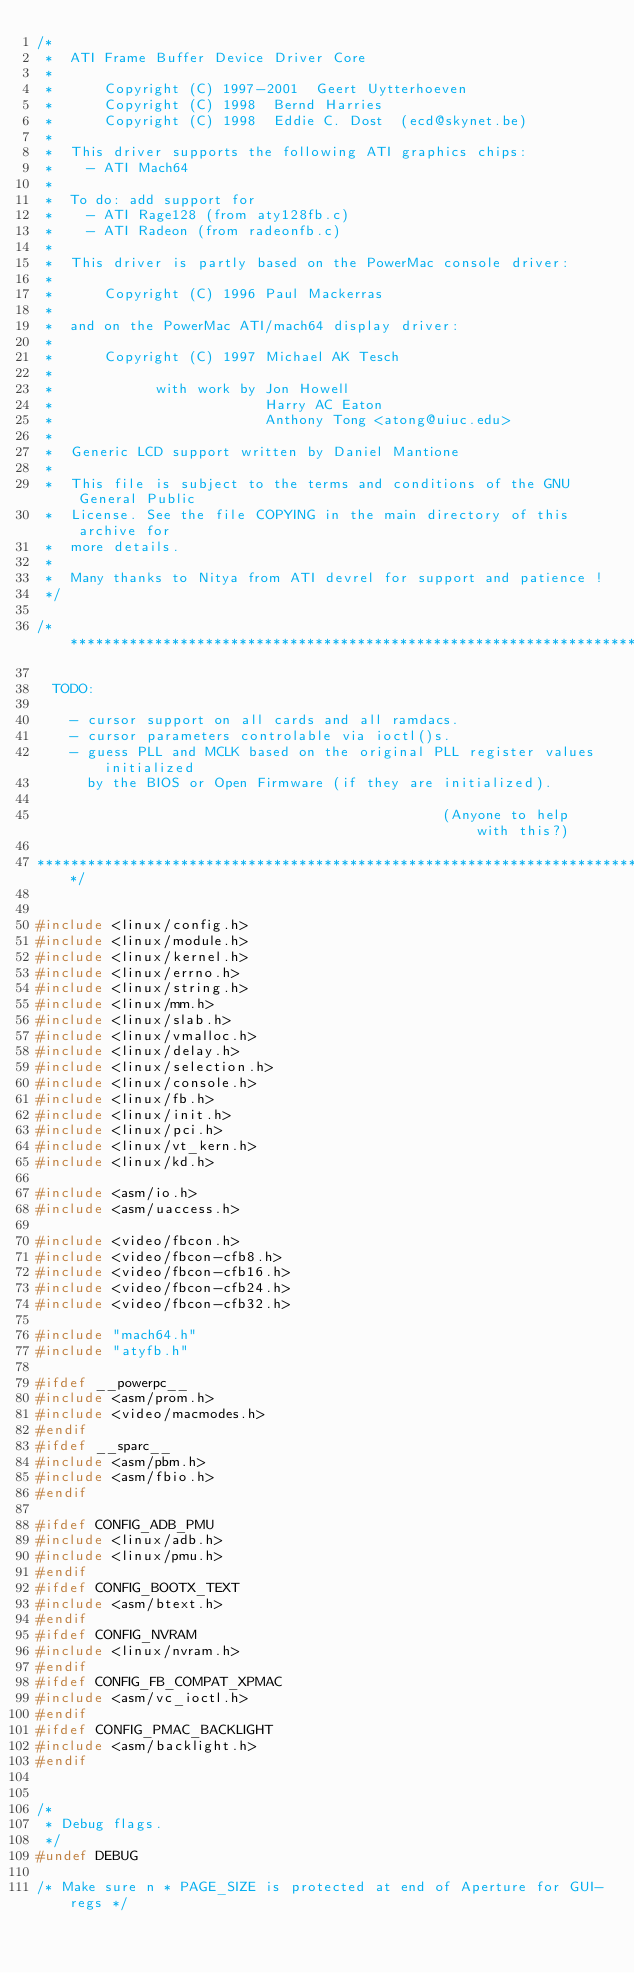<code> <loc_0><loc_0><loc_500><loc_500><_C_>/*
 *  ATI Frame Buffer Device Driver Core
 *
 *      Copyright (C) 1997-2001  Geert Uytterhoeven
 *      Copyright (C) 1998  Bernd Harries
 *      Copyright (C) 1998  Eddie C. Dost  (ecd@skynet.be)
 *
 *  This driver supports the following ATI graphics chips:
 *    - ATI Mach64
 *
 *  To do: add support for
 *    - ATI Rage128 (from aty128fb.c)
 *    - ATI Radeon (from radeonfb.c)
 *
 *  This driver is partly based on the PowerMac console driver:
 *
 *      Copyright (C) 1996 Paul Mackerras
 *
 *  and on the PowerMac ATI/mach64 display driver:
 *
 *      Copyright (C) 1997 Michael AK Tesch
 *
 *            with work by Jon Howell
 *                         Harry AC Eaton
 *                         Anthony Tong <atong@uiuc.edu>
 *
 *  Generic LCD support written by Daniel Mantione
 *
 *  This file is subject to the terms and conditions of the GNU General Public
 *  License. See the file COPYING in the main directory of this archive for
 *  more details.
 *  
 *  Many thanks to Nitya from ATI devrel for support and patience !
 */

/******************************************************************************

  TODO:

    - cursor support on all cards and all ramdacs.
    - cursor parameters controlable via ioctl()s.
    - guess PLL and MCLK based on the original PLL register values initialized
      by the BIOS or Open Firmware (if they are initialized).

                                                (Anyone to help with this?)

******************************************************************************/


#include <linux/config.h>
#include <linux/module.h>
#include <linux/kernel.h>
#include <linux/errno.h>
#include <linux/string.h>
#include <linux/mm.h>
#include <linux/slab.h>
#include <linux/vmalloc.h>
#include <linux/delay.h>
#include <linux/selection.h>
#include <linux/console.h>
#include <linux/fb.h>
#include <linux/init.h>
#include <linux/pci.h>
#include <linux/vt_kern.h>
#include <linux/kd.h>

#include <asm/io.h>
#include <asm/uaccess.h>

#include <video/fbcon.h>
#include <video/fbcon-cfb8.h>
#include <video/fbcon-cfb16.h>
#include <video/fbcon-cfb24.h>
#include <video/fbcon-cfb32.h>

#include "mach64.h"
#include "atyfb.h"

#ifdef __powerpc__
#include <asm/prom.h>
#include <video/macmodes.h>
#endif
#ifdef __sparc__
#include <asm/pbm.h>
#include <asm/fbio.h>
#endif

#ifdef CONFIG_ADB_PMU
#include <linux/adb.h>
#include <linux/pmu.h>
#endif
#ifdef CONFIG_BOOTX_TEXT
#include <asm/btext.h>
#endif
#ifdef CONFIG_NVRAM
#include <linux/nvram.h>
#endif
#ifdef CONFIG_FB_COMPAT_XPMAC
#include <asm/vc_ioctl.h>
#endif
#ifdef CONFIG_PMAC_BACKLIGHT
#include <asm/backlight.h>
#endif


/*
 * Debug flags.
 */
#undef DEBUG

/* Make sure n * PAGE_SIZE is protected at end of Aperture for GUI-regs */</code> 